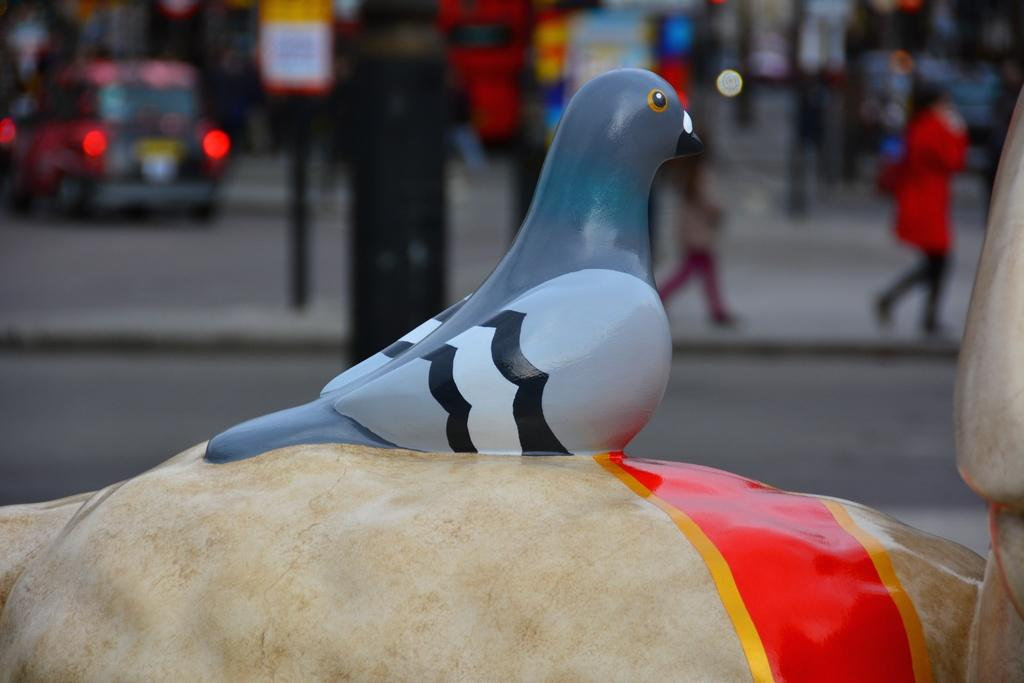What is the main subject of the image? There is a depiction of a pigeon in the center of the image. What can be seen in the background of the image? There is a road in the background of the image. Are there any vehicles visible in the image? Yes, there is a car visible in the image. What are the people in the image doing? There are people walking on the road. How does the chicken contribute to the image? There is no chicken present in the image; it only features a pigeon. 